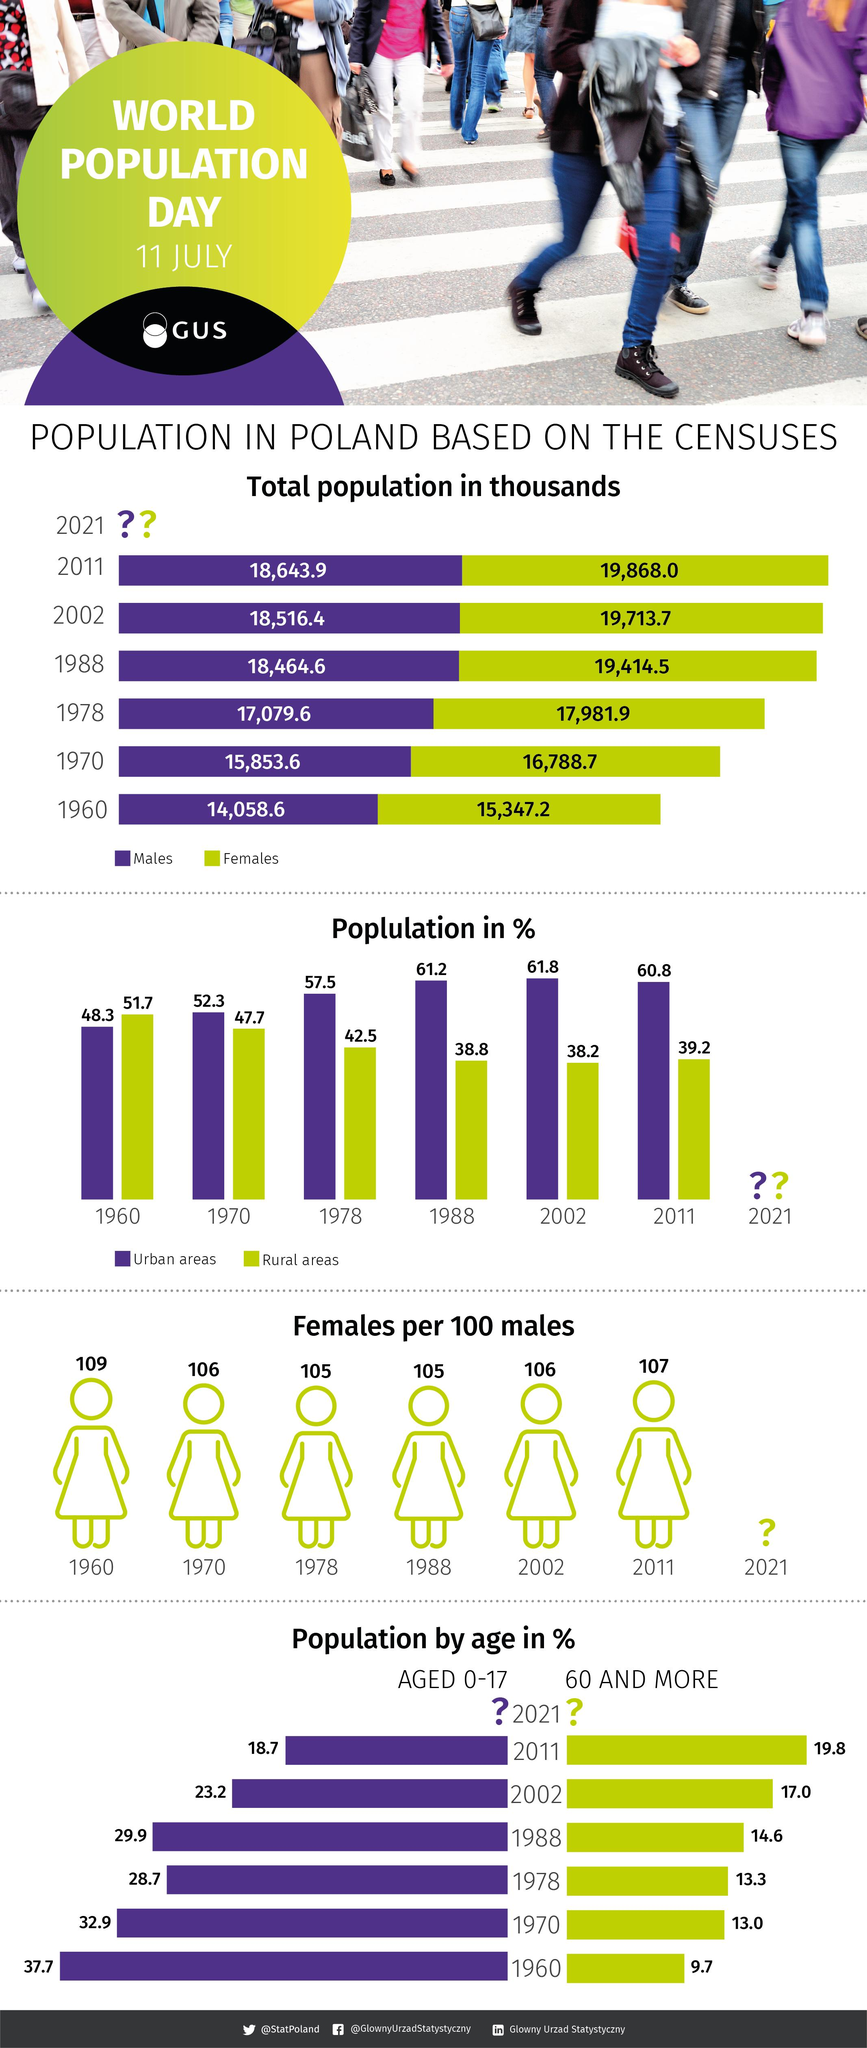Highlight a few significant elements in this photo. In 1960, the number of females in Poland was approximately 15,347.2. In 1988, the population in the urban area was the second-highest. The total population of Poland in 2011 was 38,511.9 people. The population in the rural area was the second-highest in 1970. In 1970, there were 16,788.7 females living in Poland. 